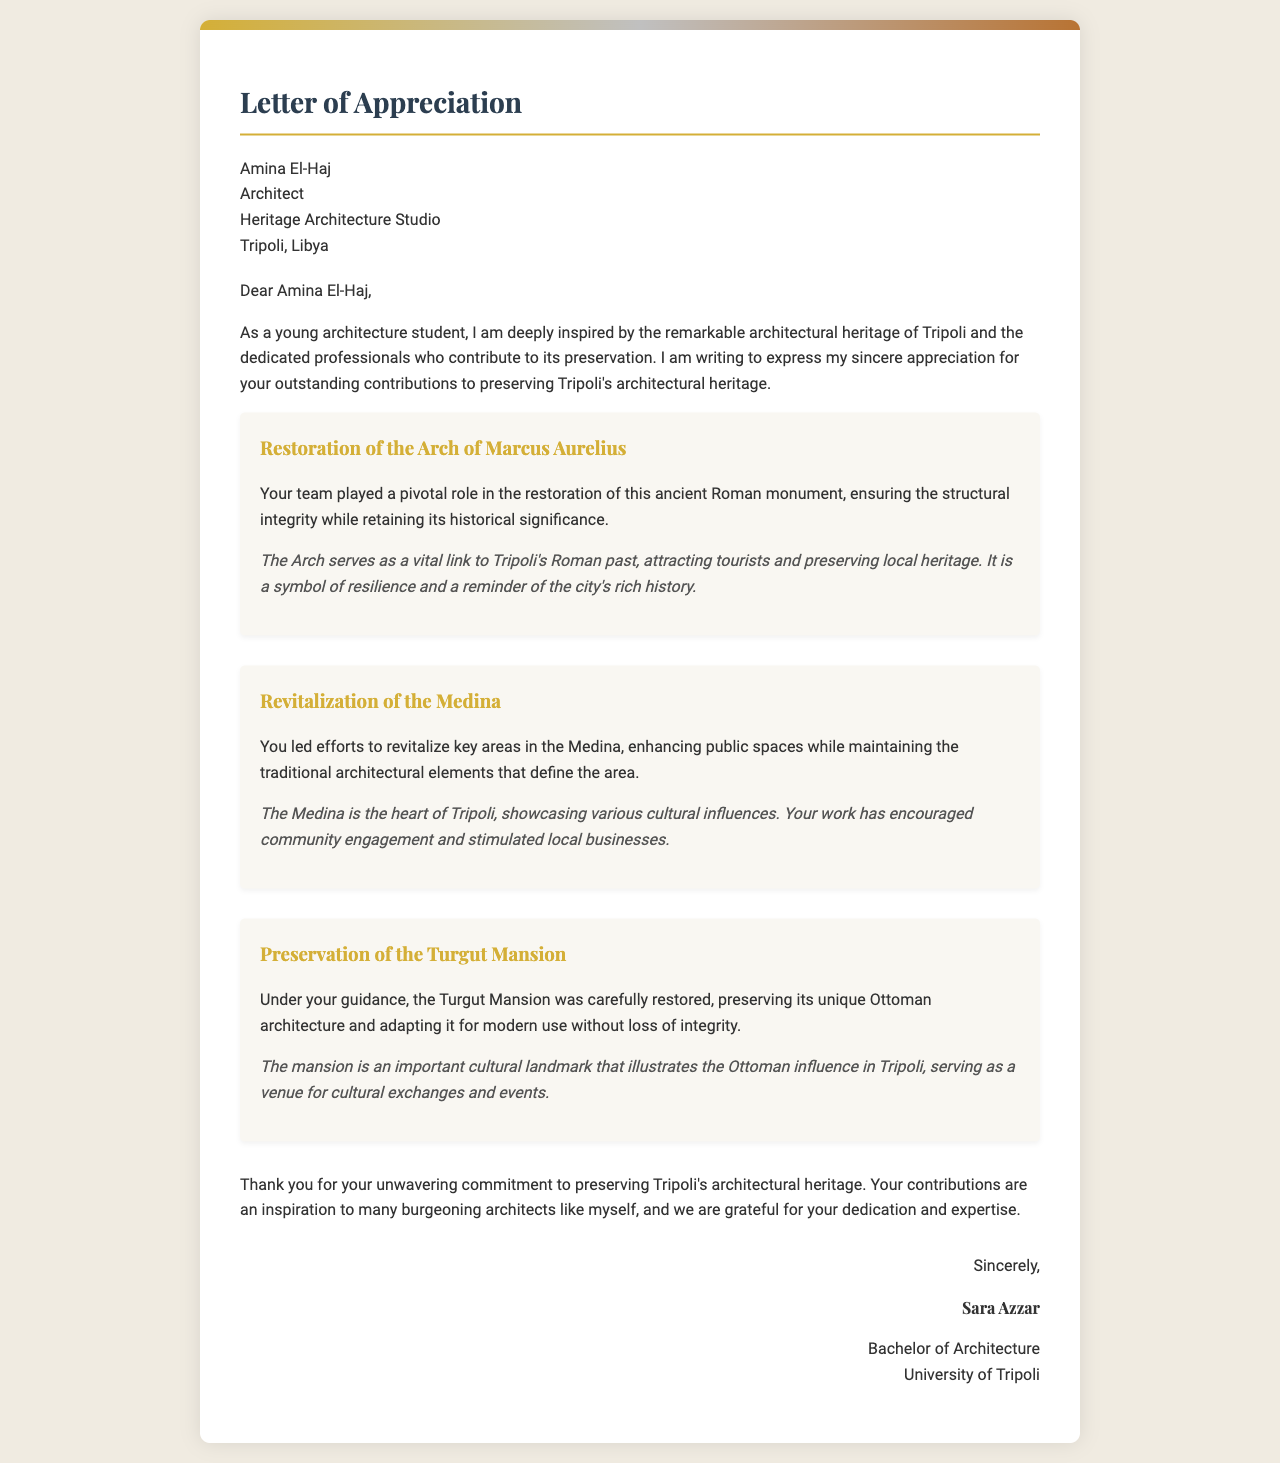What is the name of the recipient? The recipient's name is mentioned at the beginning of the letter.
Answer: Amina El-Haj What is the profession of Amina El-Haj? The letter states Amina El-Haj's profession directly under her name.
Answer: Architect Which project involved the restoration of an ancient Roman monument? This specific project is highlighted with details about its significance in the letter.
Answer: Restoration of the Arch of Marcus Aurelius What is one significant result of the revitalization of the Medina? The letter describes the impact of this project on community engagement and local businesses.
Answer: Stimulated local businesses What architectural style is the Turgut Mansion associated with? The letter explicitly mentions the architectural style preserved in the Turgut Mansion.
Answer: Ottoman architecture Who is the author of the letter? The author's name is provided at the close of the letter.
Answer: Sara Azzar What degree is the author pursuing? The letter specifies the educational program of the author.
Answer: Bachelor of Architecture What is considered the heart of Tripoli in the letter? The letter describes an area significant to Tripoli, often referred to as its cultural core.
Answer: The Medina 